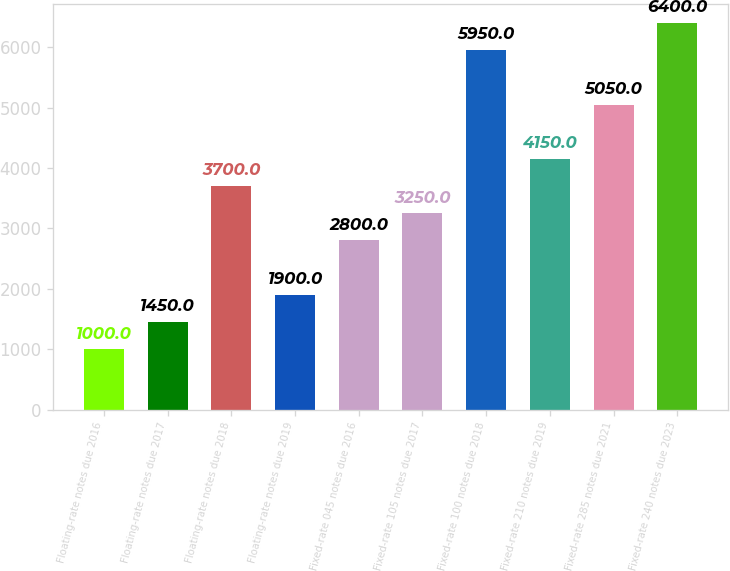<chart> <loc_0><loc_0><loc_500><loc_500><bar_chart><fcel>Floating-rate notes due 2016<fcel>Floating-rate notes due 2017<fcel>Floating-rate notes due 2018<fcel>Floating-rate notes due 2019<fcel>Fixed-rate 045 notes due 2016<fcel>Fixed-rate 105 notes due 2017<fcel>Fixed-rate 100 notes due 2018<fcel>Fixed-rate 210 notes due 2019<fcel>Fixed-rate 285 notes due 2021<fcel>Fixed-rate 240 notes due 2023<nl><fcel>1000<fcel>1450<fcel>3700<fcel>1900<fcel>2800<fcel>3250<fcel>5950<fcel>4150<fcel>5050<fcel>6400<nl></chart> 